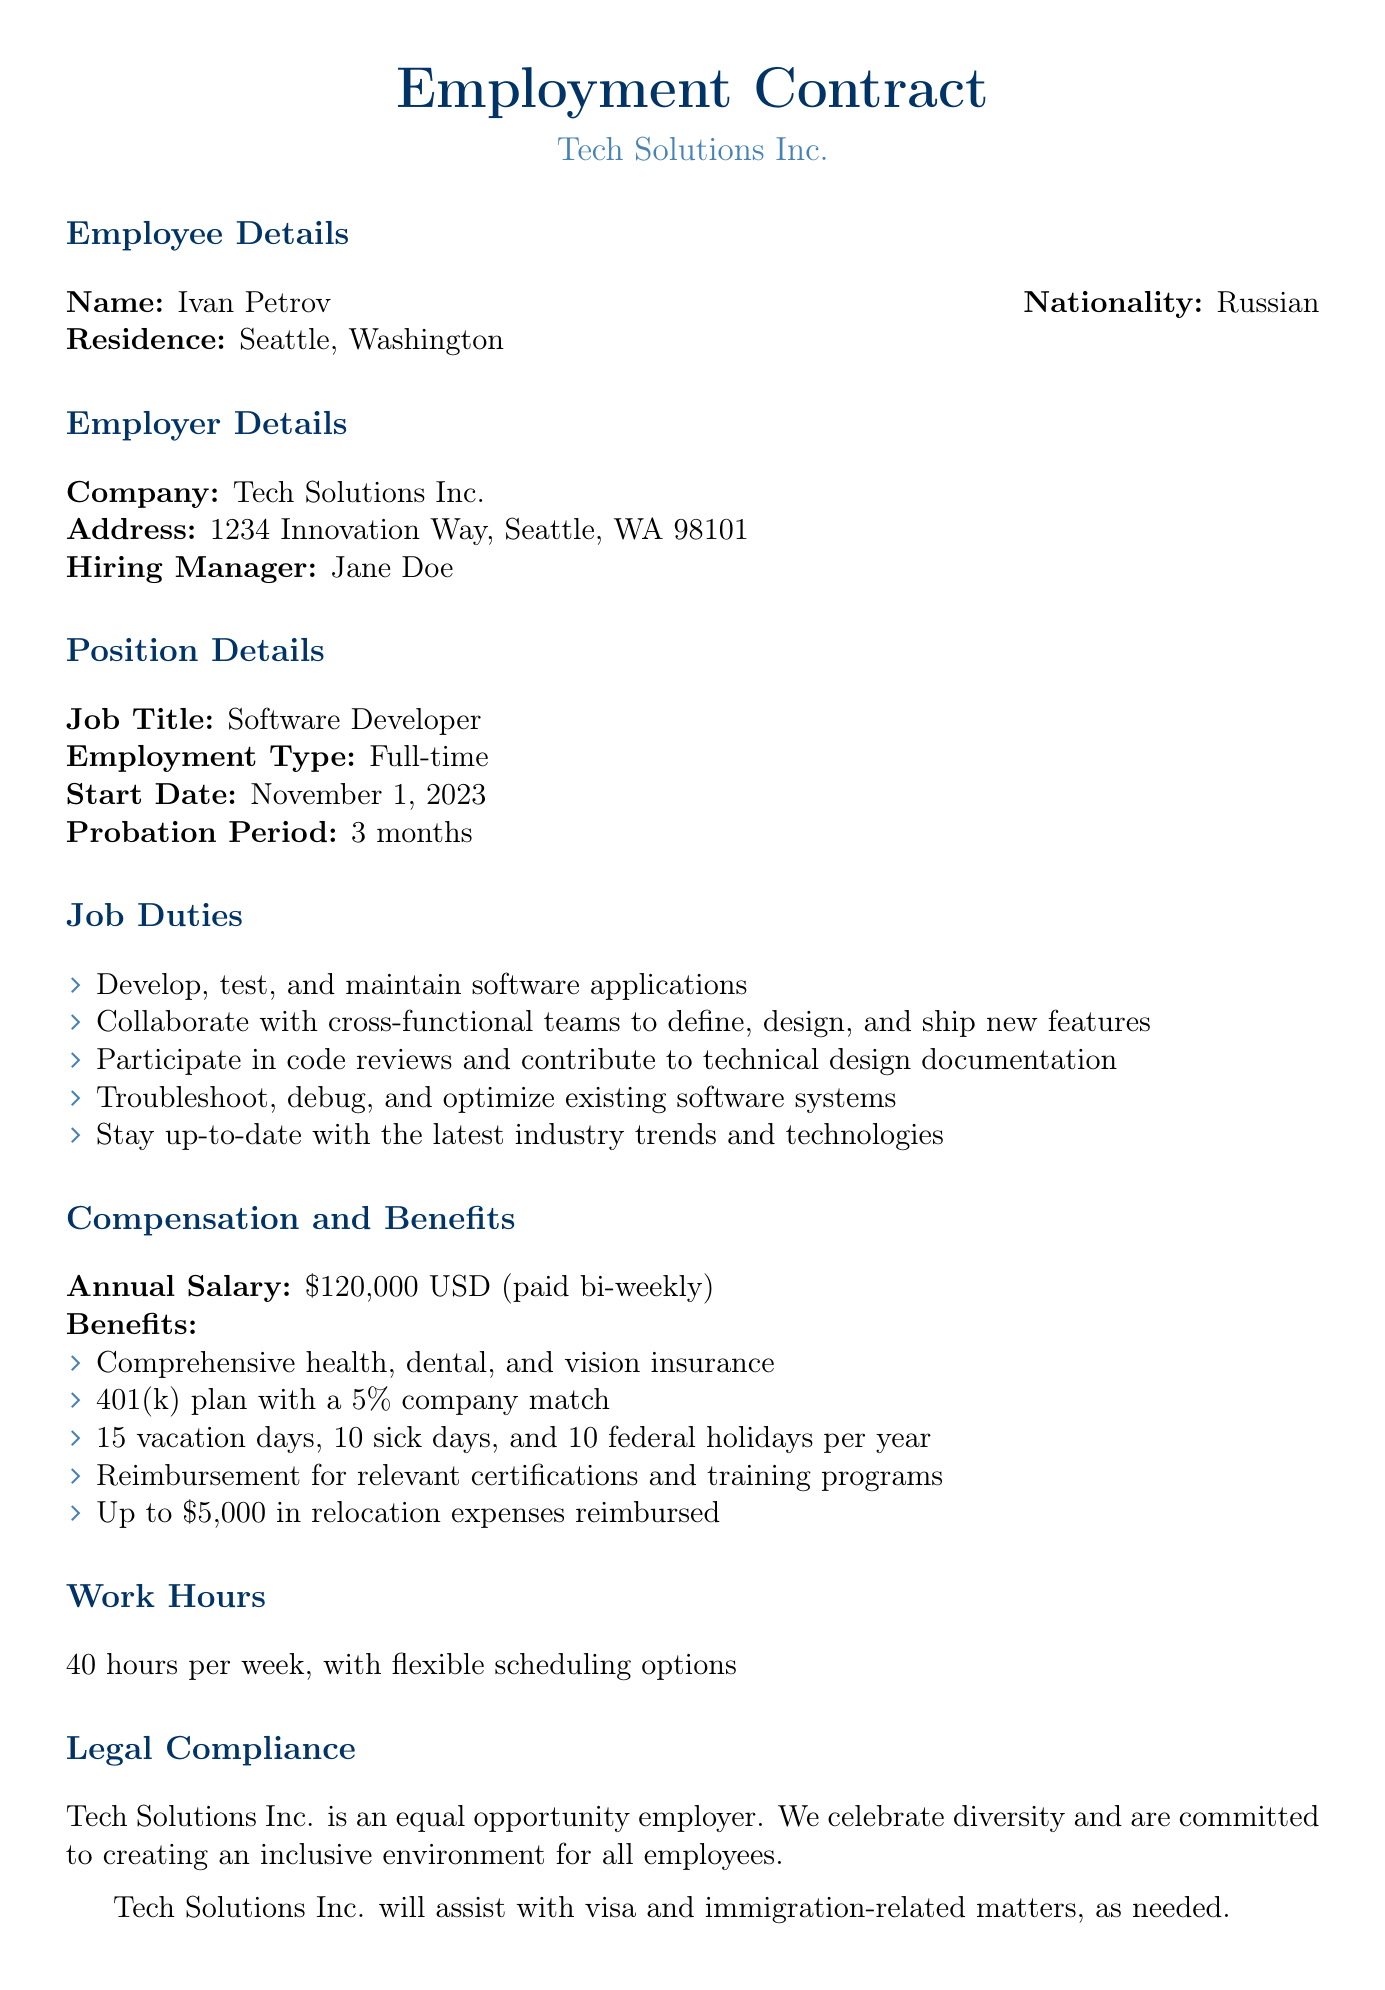What is the job title for the position? The job title is specified in the document under Position Details.
Answer: Software Developer What is the annual salary? The annual salary is mentioned under Compensation and Benefits.
Answer: $120,000 USD How long is the probation period? The probation period duration is indicated in the Position Details section.
Answer: 3 months What are the total vacation days offered? The total vacation days can be found in the Benefits section of the document.
Answer: 15 vacation days Who is the hiring manager? The hiring manager's name is provided in the Employer Details section.
Answer: Jane Doe What types of insurance are included in the benefits package? The types of insurance are listed in the Benefits section and highlight coverage included in the package.
Answer: Comprehensive health, dental, and vision insurance What is the company's policy on diversity? The document states the company's approach toward diversity and inclusion.
Answer: Equal opportunity employer What is the start date for employment? The start date is specified under the Position Details section.
Answer: November 1, 2023 What type of work hours are expected? The expected work hours are mentioned in the Work Hours section.
Answer: 40 hours per week 